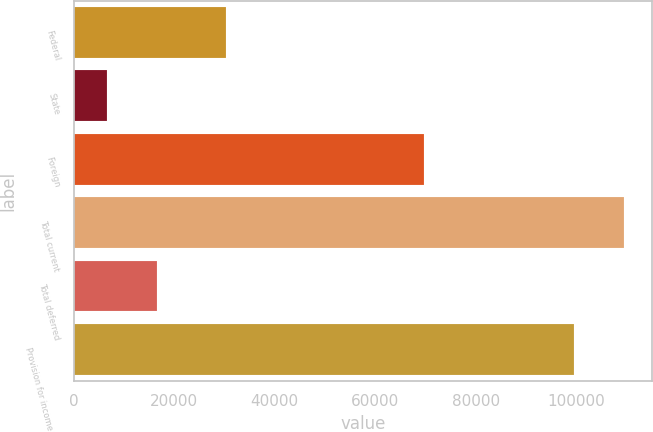Convert chart. <chart><loc_0><loc_0><loc_500><loc_500><bar_chart><fcel>Federal<fcel>State<fcel>Foreign<fcel>Total current<fcel>Total deferred<fcel>Provision for income taxes<nl><fcel>30334<fcel>6616<fcel>69793<fcel>109603<fcel>16628.7<fcel>99590<nl></chart> 